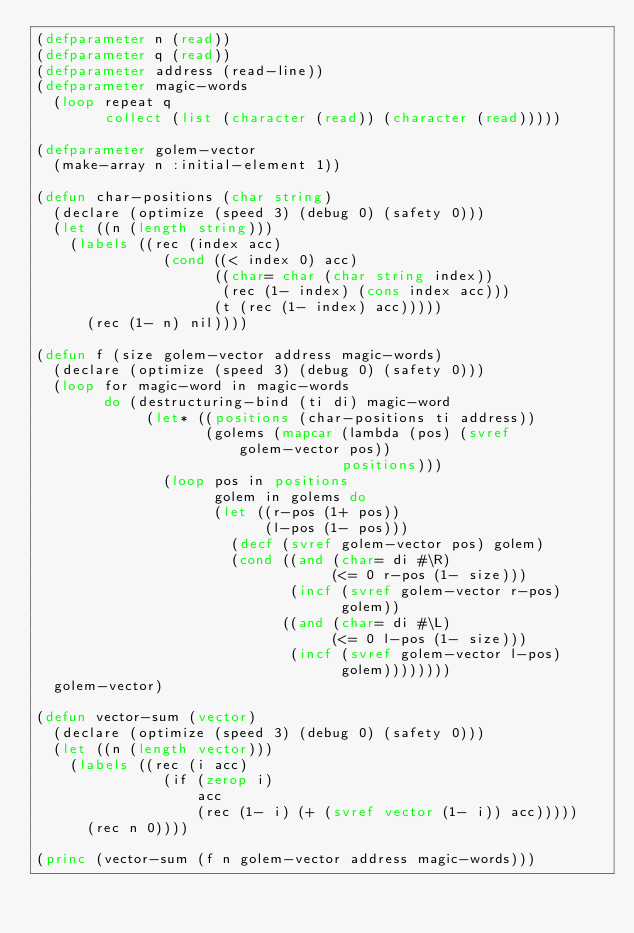Convert code to text. <code><loc_0><loc_0><loc_500><loc_500><_Lisp_>(defparameter n (read))
(defparameter q (read))
(defparameter address (read-line))
(defparameter magic-words
  (loop repeat q
        collect (list (character (read)) (character (read)))))

(defparameter golem-vector
  (make-array n :initial-element 1))

(defun char-positions (char string)
  (declare (optimize (speed 3) (debug 0) (safety 0)))
  (let ((n (length string)))
    (labels ((rec (index acc)
               (cond ((< index 0) acc)
                     ((char= char (char string index))
                      (rec (1- index) (cons index acc)))
                     (t (rec (1- index) acc)))))
      (rec (1- n) nil))))

(defun f (size golem-vector address magic-words)
  (declare (optimize (speed 3) (debug 0) (safety 0)))
  (loop for magic-word in magic-words
        do (destructuring-bind (ti di) magic-word
             (let* ((positions (char-positions ti address))
                    (golems (mapcar (lambda (pos) (svref golem-vector pos))
                                    positions)))
               (loop pos in positions
                     golem in golems do
                     (let ((r-pos (1+ pos))
                           (l-pos (1- pos)))
                       (decf (svref golem-vector pos) golem)
                       (cond ((and (char= di #\R)
                                   (<= 0 r-pos (1- size)))
                              (incf (svref golem-vector r-pos)
                                    golem))
                             ((and (char= di #\L)
                                   (<= 0 l-pos (1- size)))
                              (incf (svref golem-vector l-pos)
                                    golem))))))))
  golem-vector)

(defun vector-sum (vector)
  (declare (optimize (speed 3) (debug 0) (safety 0)))
  (let ((n (length vector)))
    (labels ((rec (i acc)
               (if (zerop i)
                   acc
                   (rec (1- i) (+ (svref vector (1- i)) acc)))))
      (rec n 0))))

(princ (vector-sum (f n golem-vector address magic-words)))
</code> 